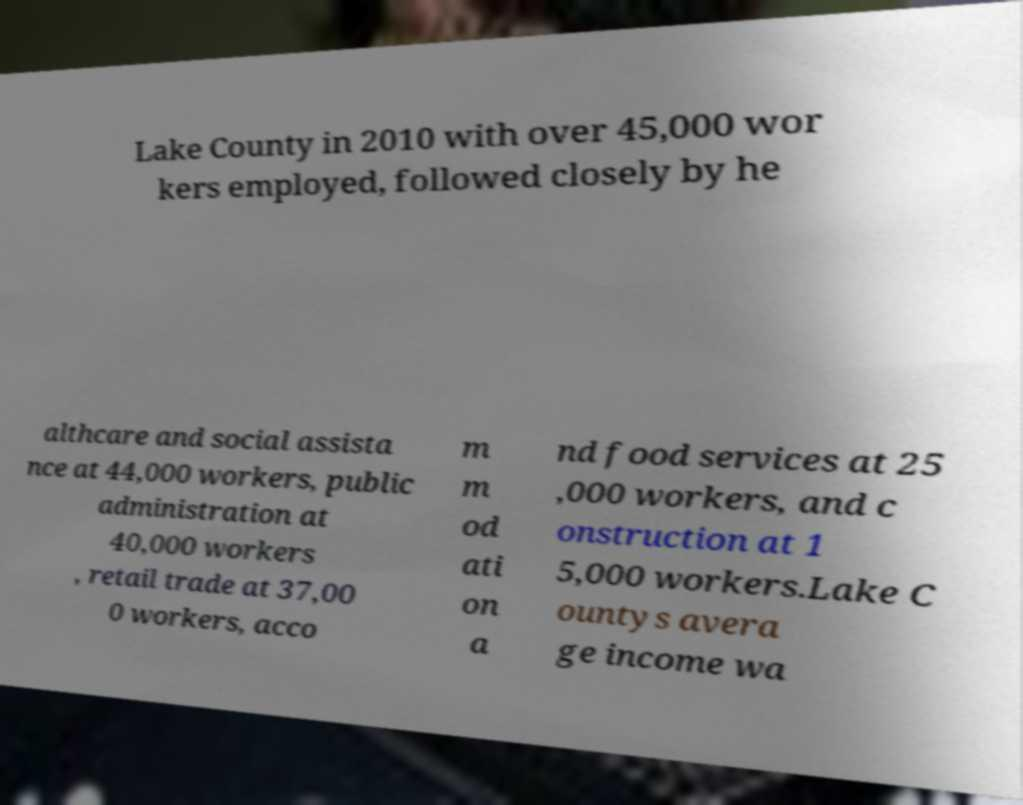Could you extract and type out the text from this image? Lake County in 2010 with over 45,000 wor kers employed, followed closely by he althcare and social assista nce at 44,000 workers, public administration at 40,000 workers , retail trade at 37,00 0 workers, acco m m od ati on a nd food services at 25 ,000 workers, and c onstruction at 1 5,000 workers.Lake C ountys avera ge income wa 